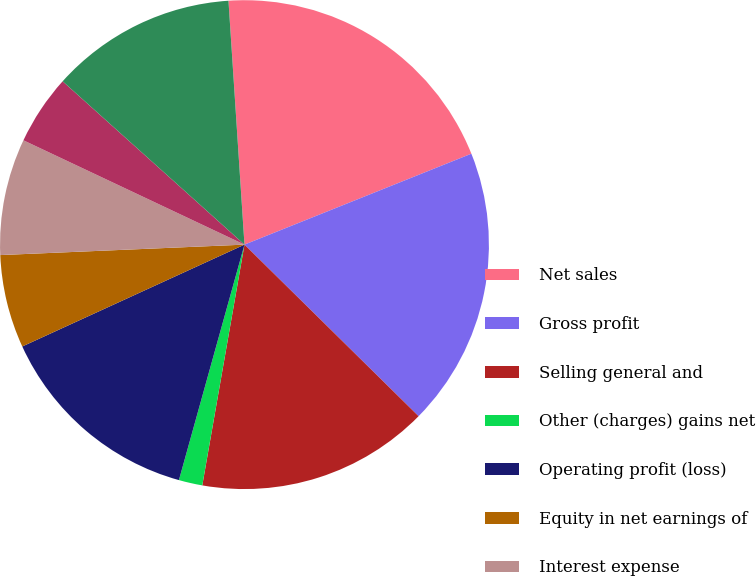Convert chart to OTSL. <chart><loc_0><loc_0><loc_500><loc_500><pie_chart><fcel>Net sales<fcel>Gross profit<fcel>Selling general and<fcel>Other (charges) gains net<fcel>Operating profit (loss)<fcel>Equity in net earnings of<fcel>Interest expense<fcel>Dividend income - cost<fcel>Earnings (loss) from<nl><fcel>19.98%<fcel>18.45%<fcel>15.38%<fcel>1.56%<fcel>13.84%<fcel>6.16%<fcel>7.7%<fcel>4.63%<fcel>12.31%<nl></chart> 